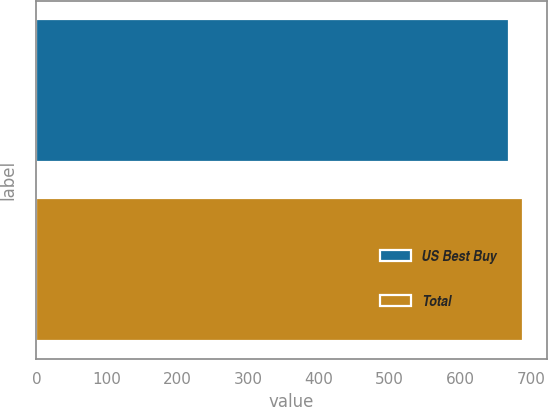Convert chart. <chart><loc_0><loc_0><loc_500><loc_500><bar_chart><fcel>US Best Buy<fcel>Total<nl><fcel>668<fcel>688<nl></chart> 